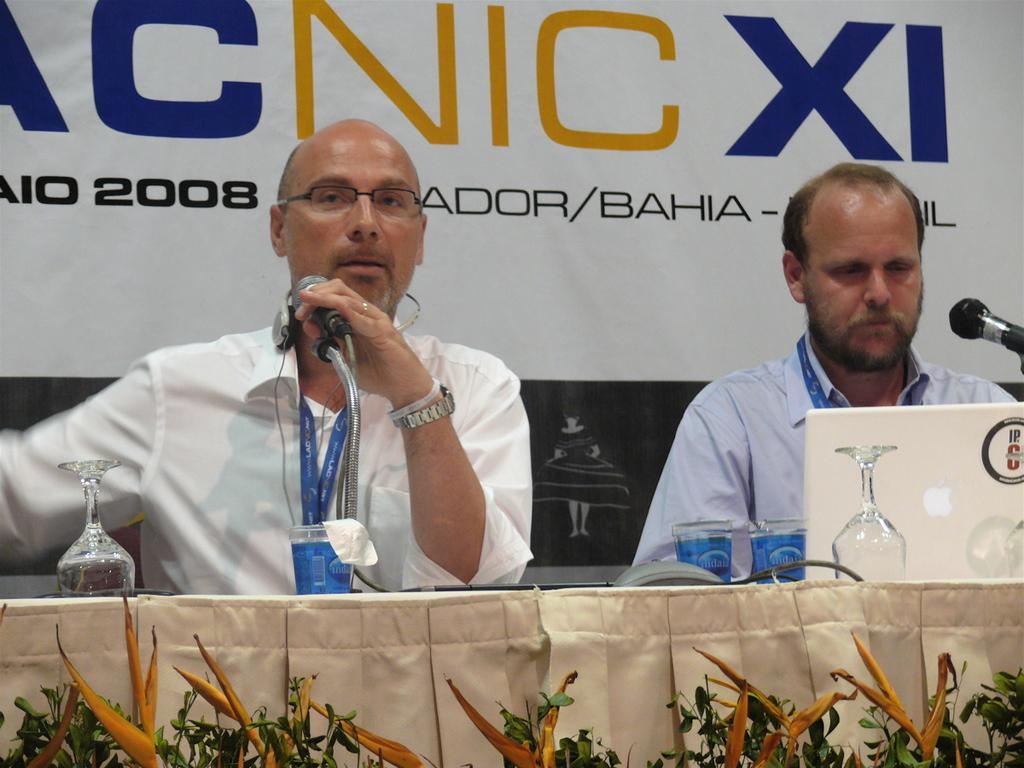How would you summarize this image in a sentence or two? In this picture there is a man who is wearing white shirt, spectacle and watch. He is holding a mic. He is sitting near to the table. On the table we can see wine glasses, water glass, laptop. On the right there is a man who is looking on the laptop. At the bottom we can see the plants. At the top there is a banner. 